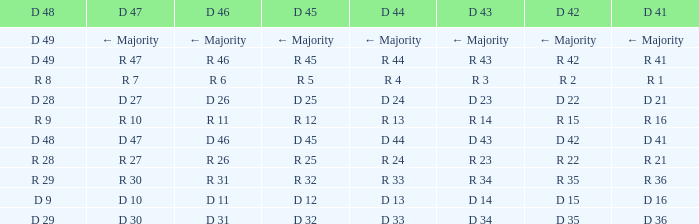Name the D 47 when it has a D 45 of d 32 D 30. 